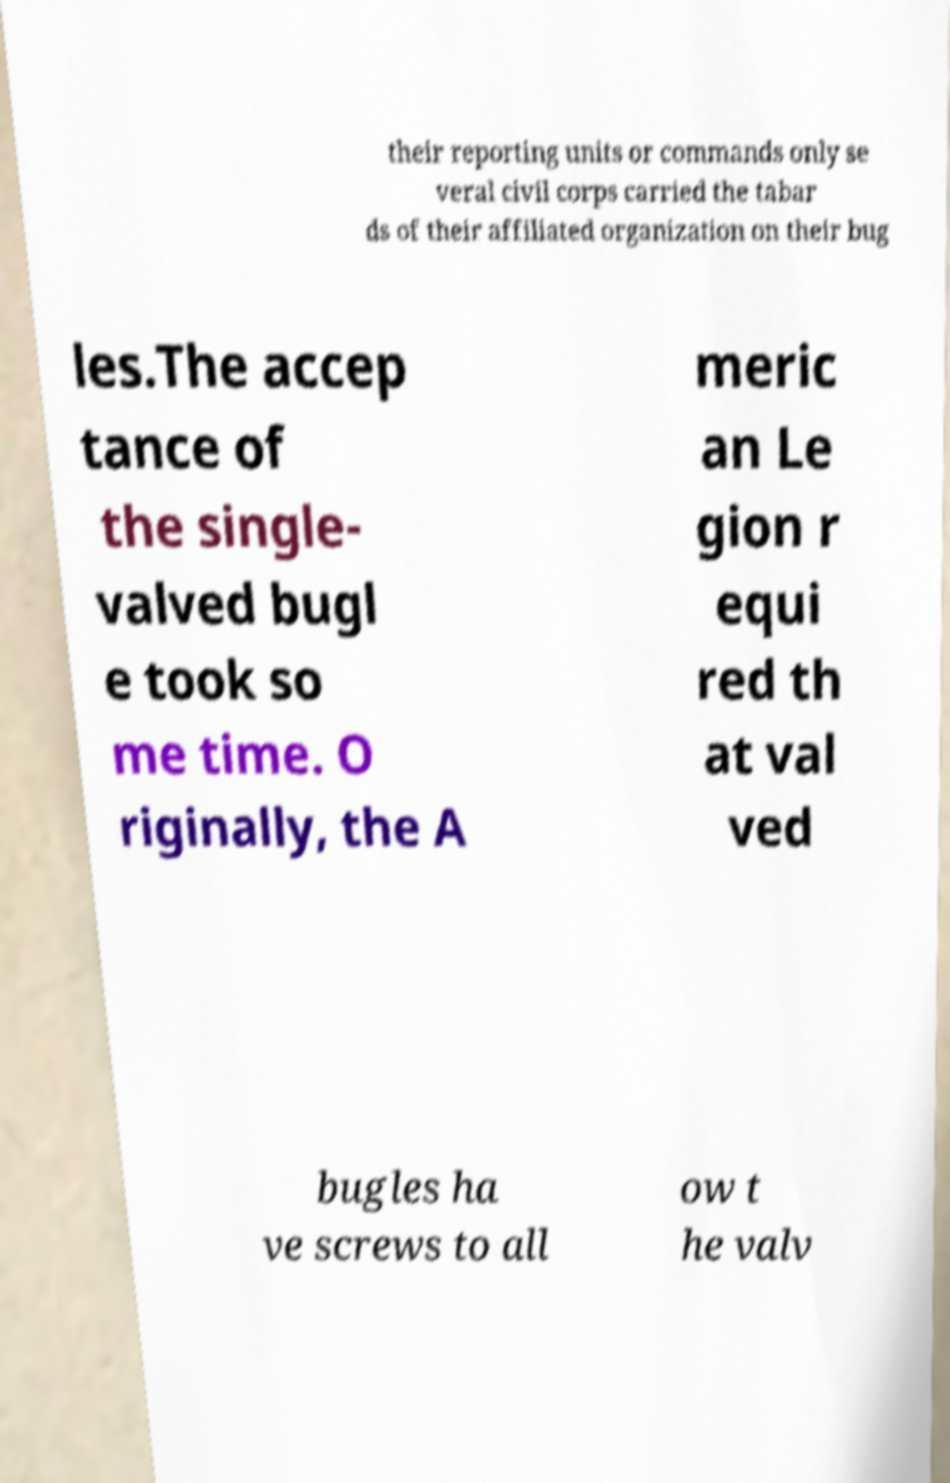Could you extract and type out the text from this image? their reporting units or commands only se veral civil corps carried the tabar ds of their affiliated organization on their bug les.The accep tance of the single- valved bugl e took so me time. O riginally, the A meric an Le gion r equi red th at val ved bugles ha ve screws to all ow t he valv 